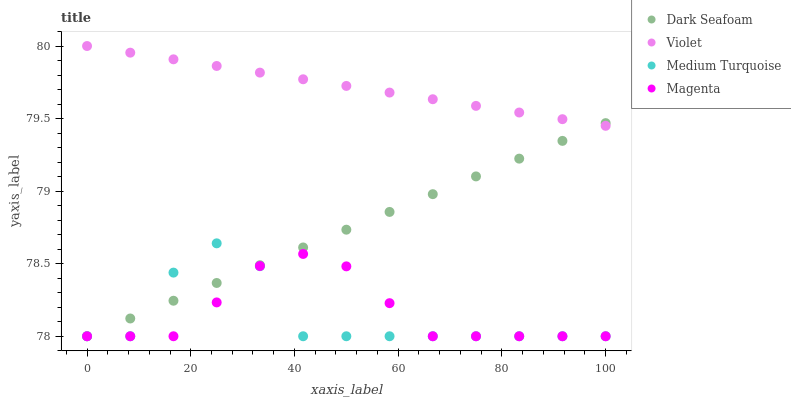Does Medium Turquoise have the minimum area under the curve?
Answer yes or no. Yes. Does Violet have the maximum area under the curve?
Answer yes or no. Yes. Does Magenta have the minimum area under the curve?
Answer yes or no. No. Does Magenta have the maximum area under the curve?
Answer yes or no. No. Is Violet the smoothest?
Answer yes or no. Yes. Is Medium Turquoise the roughest?
Answer yes or no. Yes. Is Magenta the smoothest?
Answer yes or no. No. Is Magenta the roughest?
Answer yes or no. No. Does Dark Seafoam have the lowest value?
Answer yes or no. Yes. Does Violet have the lowest value?
Answer yes or no. No. Does Violet have the highest value?
Answer yes or no. Yes. Does Medium Turquoise have the highest value?
Answer yes or no. No. Is Medium Turquoise less than Violet?
Answer yes or no. Yes. Is Violet greater than Medium Turquoise?
Answer yes or no. Yes. Does Dark Seafoam intersect Magenta?
Answer yes or no. Yes. Is Dark Seafoam less than Magenta?
Answer yes or no. No. Is Dark Seafoam greater than Magenta?
Answer yes or no. No. Does Medium Turquoise intersect Violet?
Answer yes or no. No. 